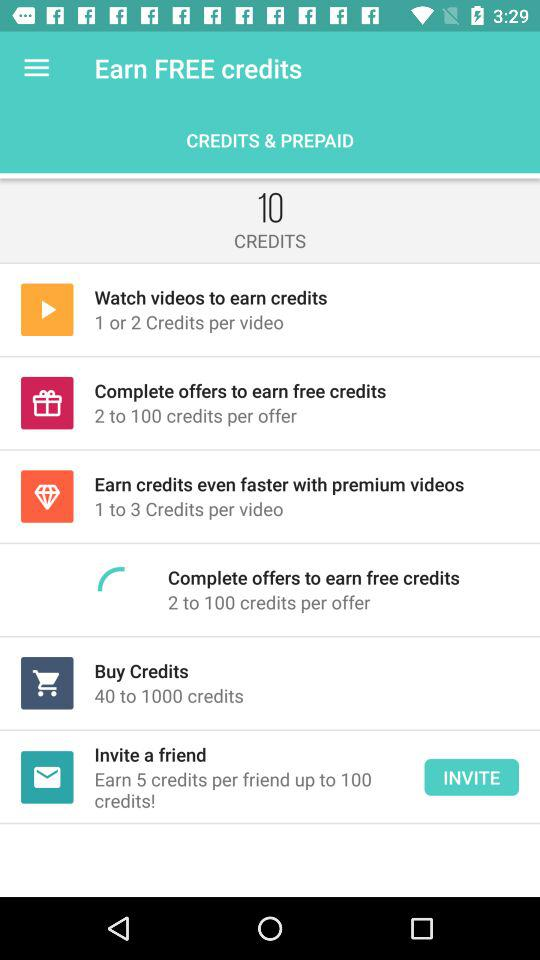How many credits can I get per video by watching videos?
Answer the question using a single word or phrase. 1 or 2 